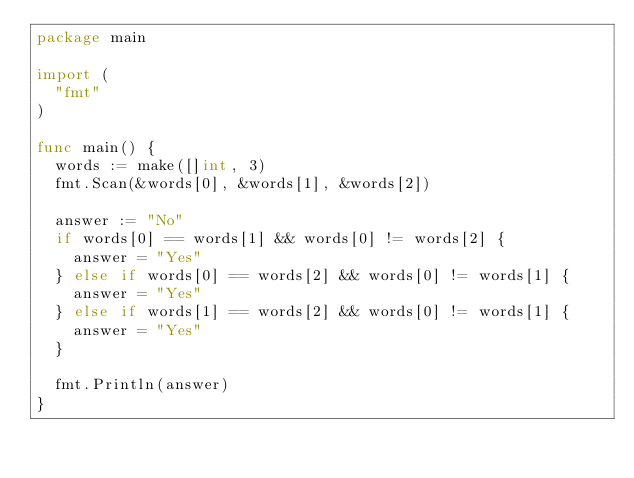Convert code to text. <code><loc_0><loc_0><loc_500><loc_500><_Go_>package main

import (
	"fmt"
)

func main() {
	words := make([]int, 3)
	fmt.Scan(&words[0], &words[1], &words[2])

	answer := "No"
	if words[0] == words[1] && words[0] != words[2] {
		answer = "Yes"
	} else if words[0] == words[2] && words[0] != words[1] {
		answer = "Yes"
	} else if words[1] == words[2] && words[0] != words[1] {
		answer = "Yes"
	}

	fmt.Println(answer)
}
</code> 